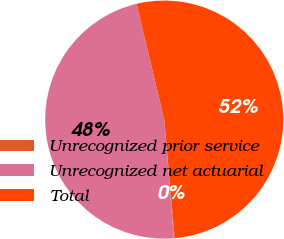<chart> <loc_0><loc_0><loc_500><loc_500><pie_chart><fcel>Unrecognized prior service<fcel>Unrecognized net actuarial<fcel>Total<nl><fcel>0.1%<fcel>47.57%<fcel>52.33%<nl></chart> 